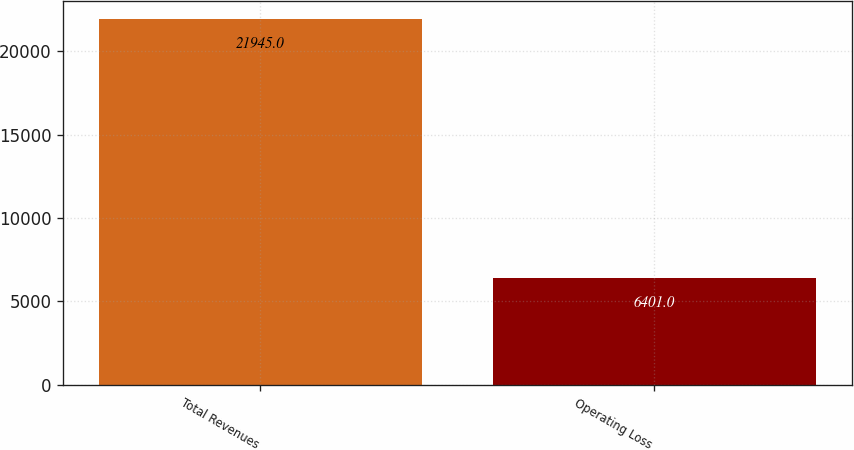Convert chart. <chart><loc_0><loc_0><loc_500><loc_500><bar_chart><fcel>Total Revenues<fcel>Operating Loss<nl><fcel>21945<fcel>6401<nl></chart> 